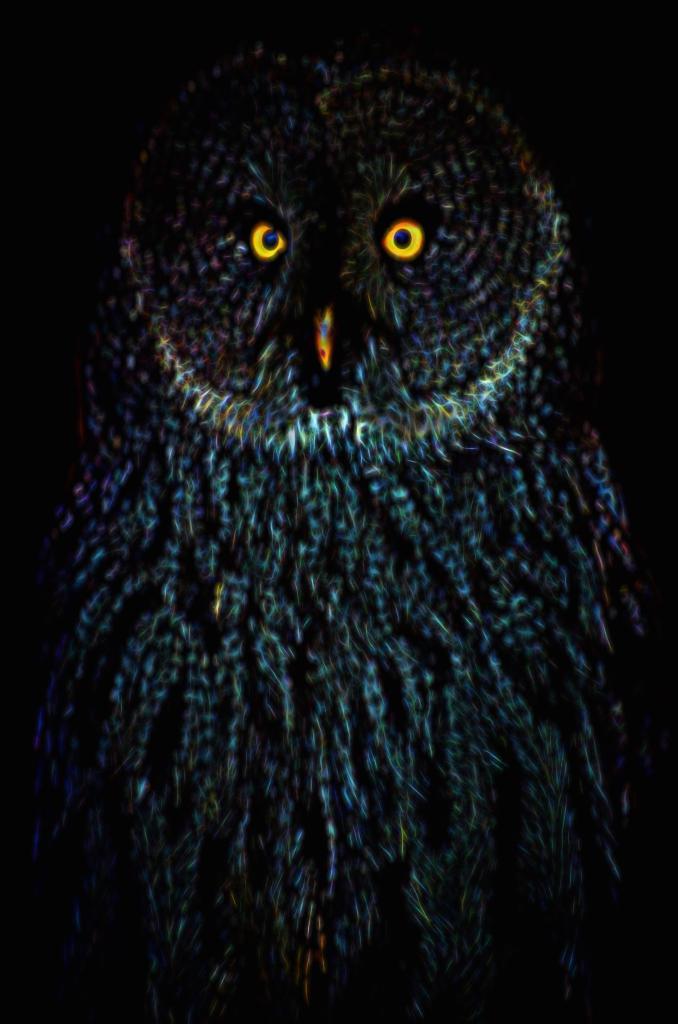Can you describe this image briefly? In this image I can see an owl in blue,white and black color. Background is in black color. 